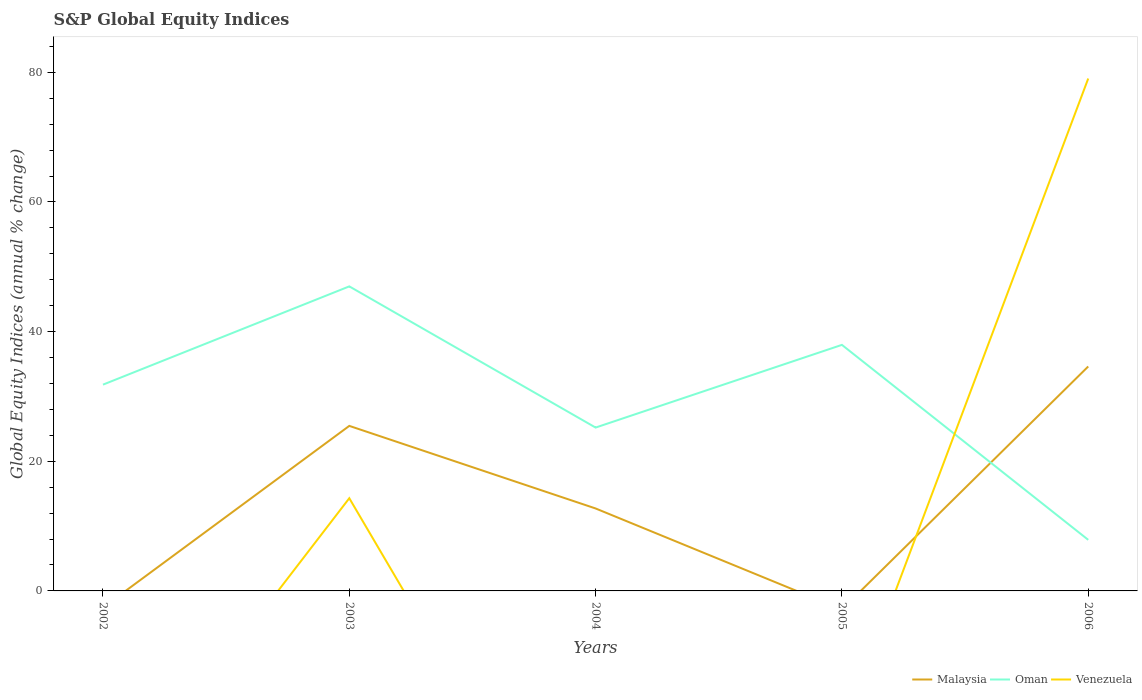How many different coloured lines are there?
Your answer should be compact. 3. Does the line corresponding to Oman intersect with the line corresponding to Venezuela?
Offer a very short reply. Yes. Is the number of lines equal to the number of legend labels?
Provide a short and direct response. No. What is the total global equity indices in Malaysia in the graph?
Keep it short and to the point. -21.9. What is the difference between the highest and the second highest global equity indices in Venezuela?
Offer a very short reply. 79.04. What is the difference between the highest and the lowest global equity indices in Malaysia?
Ensure brevity in your answer.  2. Is the global equity indices in Malaysia strictly greater than the global equity indices in Oman over the years?
Provide a short and direct response. No. How many lines are there?
Your answer should be compact. 3. What is the difference between two consecutive major ticks on the Y-axis?
Your response must be concise. 20. Are the values on the major ticks of Y-axis written in scientific E-notation?
Provide a succinct answer. No. Does the graph contain any zero values?
Provide a succinct answer. Yes. What is the title of the graph?
Your answer should be compact. S&P Global Equity Indices. Does "Uruguay" appear as one of the legend labels in the graph?
Your answer should be very brief. No. What is the label or title of the Y-axis?
Provide a succinct answer. Global Equity Indices (annual % change). What is the Global Equity Indices (annual % change) of Oman in 2002?
Your answer should be compact. 31.82. What is the Global Equity Indices (annual % change) in Malaysia in 2003?
Make the answer very short. 25.46. What is the Global Equity Indices (annual % change) in Oman in 2003?
Make the answer very short. 46.98. What is the Global Equity Indices (annual % change) in Venezuela in 2003?
Provide a short and direct response. 14.3. What is the Global Equity Indices (annual % change) in Malaysia in 2004?
Offer a very short reply. 12.72. What is the Global Equity Indices (annual % change) in Oman in 2004?
Give a very brief answer. 25.2. What is the Global Equity Indices (annual % change) of Oman in 2005?
Provide a succinct answer. 37.96. What is the Global Equity Indices (annual % change) of Malaysia in 2006?
Make the answer very short. 34.62. What is the Global Equity Indices (annual % change) in Oman in 2006?
Your answer should be compact. 7.88. What is the Global Equity Indices (annual % change) of Venezuela in 2006?
Ensure brevity in your answer.  79.04. Across all years, what is the maximum Global Equity Indices (annual % change) in Malaysia?
Make the answer very short. 34.62. Across all years, what is the maximum Global Equity Indices (annual % change) in Oman?
Your answer should be compact. 46.98. Across all years, what is the maximum Global Equity Indices (annual % change) of Venezuela?
Make the answer very short. 79.04. Across all years, what is the minimum Global Equity Indices (annual % change) in Malaysia?
Make the answer very short. 0. Across all years, what is the minimum Global Equity Indices (annual % change) in Oman?
Offer a very short reply. 7.88. Across all years, what is the minimum Global Equity Indices (annual % change) of Venezuela?
Keep it short and to the point. 0. What is the total Global Equity Indices (annual % change) in Malaysia in the graph?
Offer a terse response. 72.8. What is the total Global Equity Indices (annual % change) of Oman in the graph?
Offer a very short reply. 149.84. What is the total Global Equity Indices (annual % change) in Venezuela in the graph?
Ensure brevity in your answer.  93.34. What is the difference between the Global Equity Indices (annual % change) in Oman in 2002 and that in 2003?
Keep it short and to the point. -15.16. What is the difference between the Global Equity Indices (annual % change) in Oman in 2002 and that in 2004?
Provide a succinct answer. 6.62. What is the difference between the Global Equity Indices (annual % change) in Oman in 2002 and that in 2005?
Offer a terse response. -6.14. What is the difference between the Global Equity Indices (annual % change) of Oman in 2002 and that in 2006?
Provide a succinct answer. 23.94. What is the difference between the Global Equity Indices (annual % change) in Malaysia in 2003 and that in 2004?
Your answer should be compact. 12.74. What is the difference between the Global Equity Indices (annual % change) in Oman in 2003 and that in 2004?
Make the answer very short. 21.78. What is the difference between the Global Equity Indices (annual % change) of Oman in 2003 and that in 2005?
Make the answer very short. 9.02. What is the difference between the Global Equity Indices (annual % change) in Malaysia in 2003 and that in 2006?
Offer a terse response. -9.16. What is the difference between the Global Equity Indices (annual % change) of Oman in 2003 and that in 2006?
Your answer should be compact. 39.1. What is the difference between the Global Equity Indices (annual % change) of Venezuela in 2003 and that in 2006?
Provide a short and direct response. -64.74. What is the difference between the Global Equity Indices (annual % change) of Oman in 2004 and that in 2005?
Provide a short and direct response. -12.76. What is the difference between the Global Equity Indices (annual % change) of Malaysia in 2004 and that in 2006?
Provide a succinct answer. -21.9. What is the difference between the Global Equity Indices (annual % change) of Oman in 2004 and that in 2006?
Your response must be concise. 17.32. What is the difference between the Global Equity Indices (annual % change) in Oman in 2005 and that in 2006?
Provide a short and direct response. 30.08. What is the difference between the Global Equity Indices (annual % change) in Oman in 2002 and the Global Equity Indices (annual % change) in Venezuela in 2003?
Your answer should be compact. 17.52. What is the difference between the Global Equity Indices (annual % change) in Oman in 2002 and the Global Equity Indices (annual % change) in Venezuela in 2006?
Provide a succinct answer. -47.22. What is the difference between the Global Equity Indices (annual % change) of Malaysia in 2003 and the Global Equity Indices (annual % change) of Oman in 2004?
Your answer should be compact. 0.26. What is the difference between the Global Equity Indices (annual % change) in Malaysia in 2003 and the Global Equity Indices (annual % change) in Oman in 2005?
Provide a short and direct response. -12.5. What is the difference between the Global Equity Indices (annual % change) in Malaysia in 2003 and the Global Equity Indices (annual % change) in Oman in 2006?
Your answer should be very brief. 17.58. What is the difference between the Global Equity Indices (annual % change) of Malaysia in 2003 and the Global Equity Indices (annual % change) of Venezuela in 2006?
Offer a terse response. -53.58. What is the difference between the Global Equity Indices (annual % change) of Oman in 2003 and the Global Equity Indices (annual % change) of Venezuela in 2006?
Ensure brevity in your answer.  -32.06. What is the difference between the Global Equity Indices (annual % change) in Malaysia in 2004 and the Global Equity Indices (annual % change) in Oman in 2005?
Ensure brevity in your answer.  -25.24. What is the difference between the Global Equity Indices (annual % change) in Malaysia in 2004 and the Global Equity Indices (annual % change) in Oman in 2006?
Give a very brief answer. 4.84. What is the difference between the Global Equity Indices (annual % change) in Malaysia in 2004 and the Global Equity Indices (annual % change) in Venezuela in 2006?
Provide a succinct answer. -66.32. What is the difference between the Global Equity Indices (annual % change) in Oman in 2004 and the Global Equity Indices (annual % change) in Venezuela in 2006?
Your answer should be very brief. -53.84. What is the difference between the Global Equity Indices (annual % change) of Oman in 2005 and the Global Equity Indices (annual % change) of Venezuela in 2006?
Ensure brevity in your answer.  -41.09. What is the average Global Equity Indices (annual % change) in Malaysia per year?
Your answer should be very brief. 14.56. What is the average Global Equity Indices (annual % change) of Oman per year?
Your response must be concise. 29.97. What is the average Global Equity Indices (annual % change) of Venezuela per year?
Offer a terse response. 18.67. In the year 2003, what is the difference between the Global Equity Indices (annual % change) in Malaysia and Global Equity Indices (annual % change) in Oman?
Provide a short and direct response. -21.52. In the year 2003, what is the difference between the Global Equity Indices (annual % change) in Malaysia and Global Equity Indices (annual % change) in Venezuela?
Give a very brief answer. 11.16. In the year 2003, what is the difference between the Global Equity Indices (annual % change) of Oman and Global Equity Indices (annual % change) of Venezuela?
Offer a terse response. 32.68. In the year 2004, what is the difference between the Global Equity Indices (annual % change) in Malaysia and Global Equity Indices (annual % change) in Oman?
Provide a succinct answer. -12.48. In the year 2006, what is the difference between the Global Equity Indices (annual % change) of Malaysia and Global Equity Indices (annual % change) of Oman?
Your response must be concise. 26.74. In the year 2006, what is the difference between the Global Equity Indices (annual % change) in Malaysia and Global Equity Indices (annual % change) in Venezuela?
Offer a very short reply. -44.42. In the year 2006, what is the difference between the Global Equity Indices (annual % change) of Oman and Global Equity Indices (annual % change) of Venezuela?
Your answer should be very brief. -71.16. What is the ratio of the Global Equity Indices (annual % change) of Oman in 2002 to that in 2003?
Your answer should be very brief. 0.68. What is the ratio of the Global Equity Indices (annual % change) in Oman in 2002 to that in 2004?
Your answer should be very brief. 1.26. What is the ratio of the Global Equity Indices (annual % change) in Oman in 2002 to that in 2005?
Offer a terse response. 0.84. What is the ratio of the Global Equity Indices (annual % change) of Oman in 2002 to that in 2006?
Make the answer very short. 4.04. What is the ratio of the Global Equity Indices (annual % change) of Malaysia in 2003 to that in 2004?
Your response must be concise. 2. What is the ratio of the Global Equity Indices (annual % change) in Oman in 2003 to that in 2004?
Keep it short and to the point. 1.86. What is the ratio of the Global Equity Indices (annual % change) of Oman in 2003 to that in 2005?
Give a very brief answer. 1.24. What is the ratio of the Global Equity Indices (annual % change) in Malaysia in 2003 to that in 2006?
Your response must be concise. 0.74. What is the ratio of the Global Equity Indices (annual % change) in Oman in 2003 to that in 2006?
Keep it short and to the point. 5.96. What is the ratio of the Global Equity Indices (annual % change) of Venezuela in 2003 to that in 2006?
Your response must be concise. 0.18. What is the ratio of the Global Equity Indices (annual % change) of Oman in 2004 to that in 2005?
Your response must be concise. 0.66. What is the ratio of the Global Equity Indices (annual % change) in Malaysia in 2004 to that in 2006?
Offer a very short reply. 0.37. What is the ratio of the Global Equity Indices (annual % change) of Oman in 2004 to that in 2006?
Make the answer very short. 3.2. What is the ratio of the Global Equity Indices (annual % change) of Oman in 2005 to that in 2006?
Provide a short and direct response. 4.82. What is the difference between the highest and the second highest Global Equity Indices (annual % change) of Malaysia?
Offer a terse response. 9.16. What is the difference between the highest and the second highest Global Equity Indices (annual % change) of Oman?
Give a very brief answer. 9.02. What is the difference between the highest and the lowest Global Equity Indices (annual % change) in Malaysia?
Provide a succinct answer. 34.62. What is the difference between the highest and the lowest Global Equity Indices (annual % change) of Oman?
Give a very brief answer. 39.1. What is the difference between the highest and the lowest Global Equity Indices (annual % change) in Venezuela?
Make the answer very short. 79.04. 